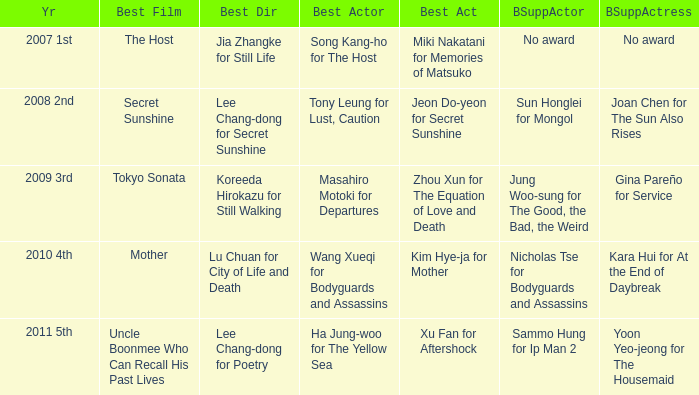Name the year for sammo hung for ip man 2 2011 5th. 